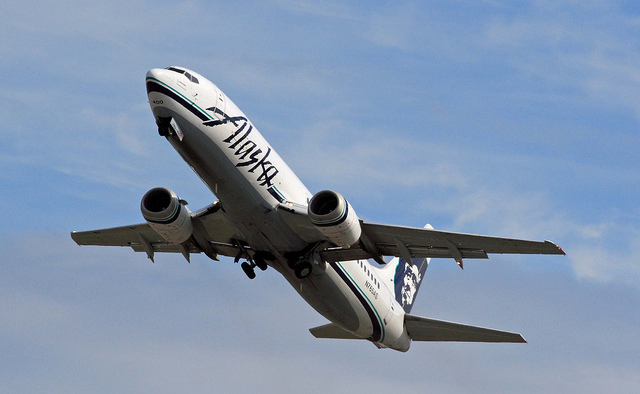Read and extract the text from this image. Alaska 